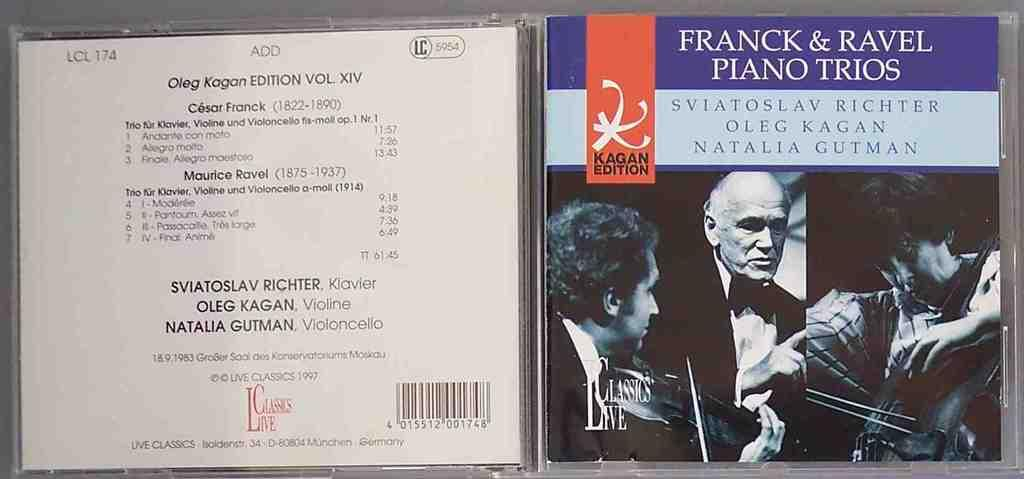<image>
Create a compact narrative representing the image presented. a CD that is from Franck and Ravel Piano Trios 